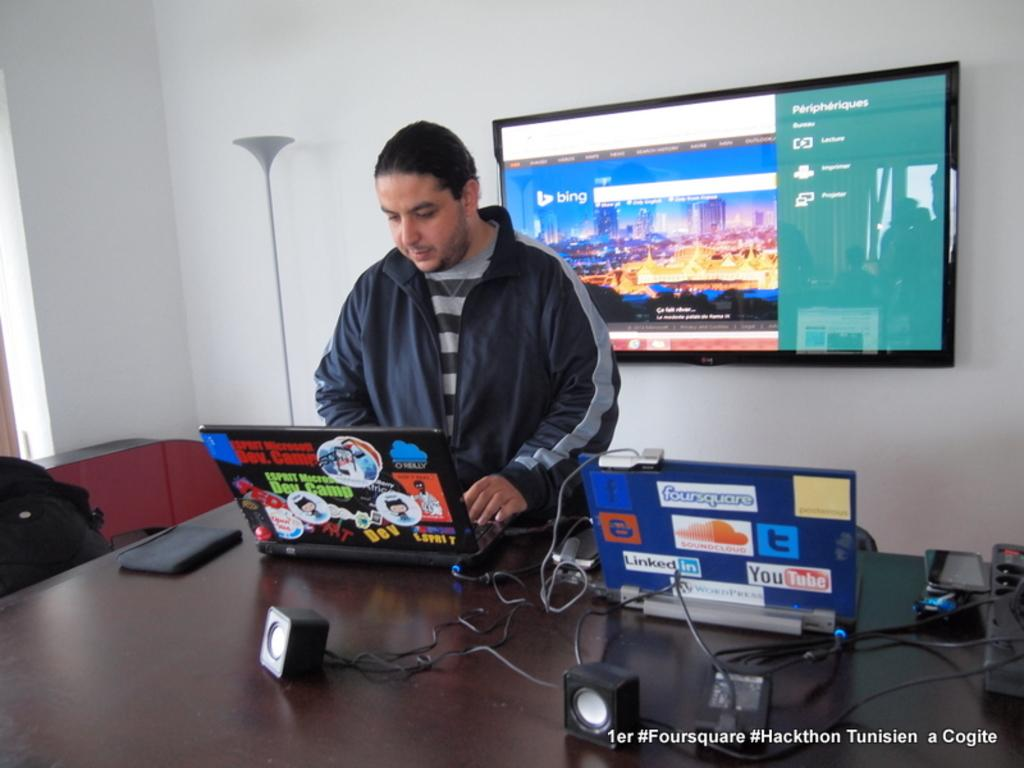What piece of furniture is present in the image? There is a table in the image. Who is near the table in the image? A man is standing near the table. What else can be seen beside the table? There are other objects beside the table. What is on the wall in the image? There is a TV screen on the wall. What type of cow can be seen walking down the alley in the image? There is no cow or alley present in the image. What joke is the man telling near the table in the image? There is no indication of a joke being told in the image. 